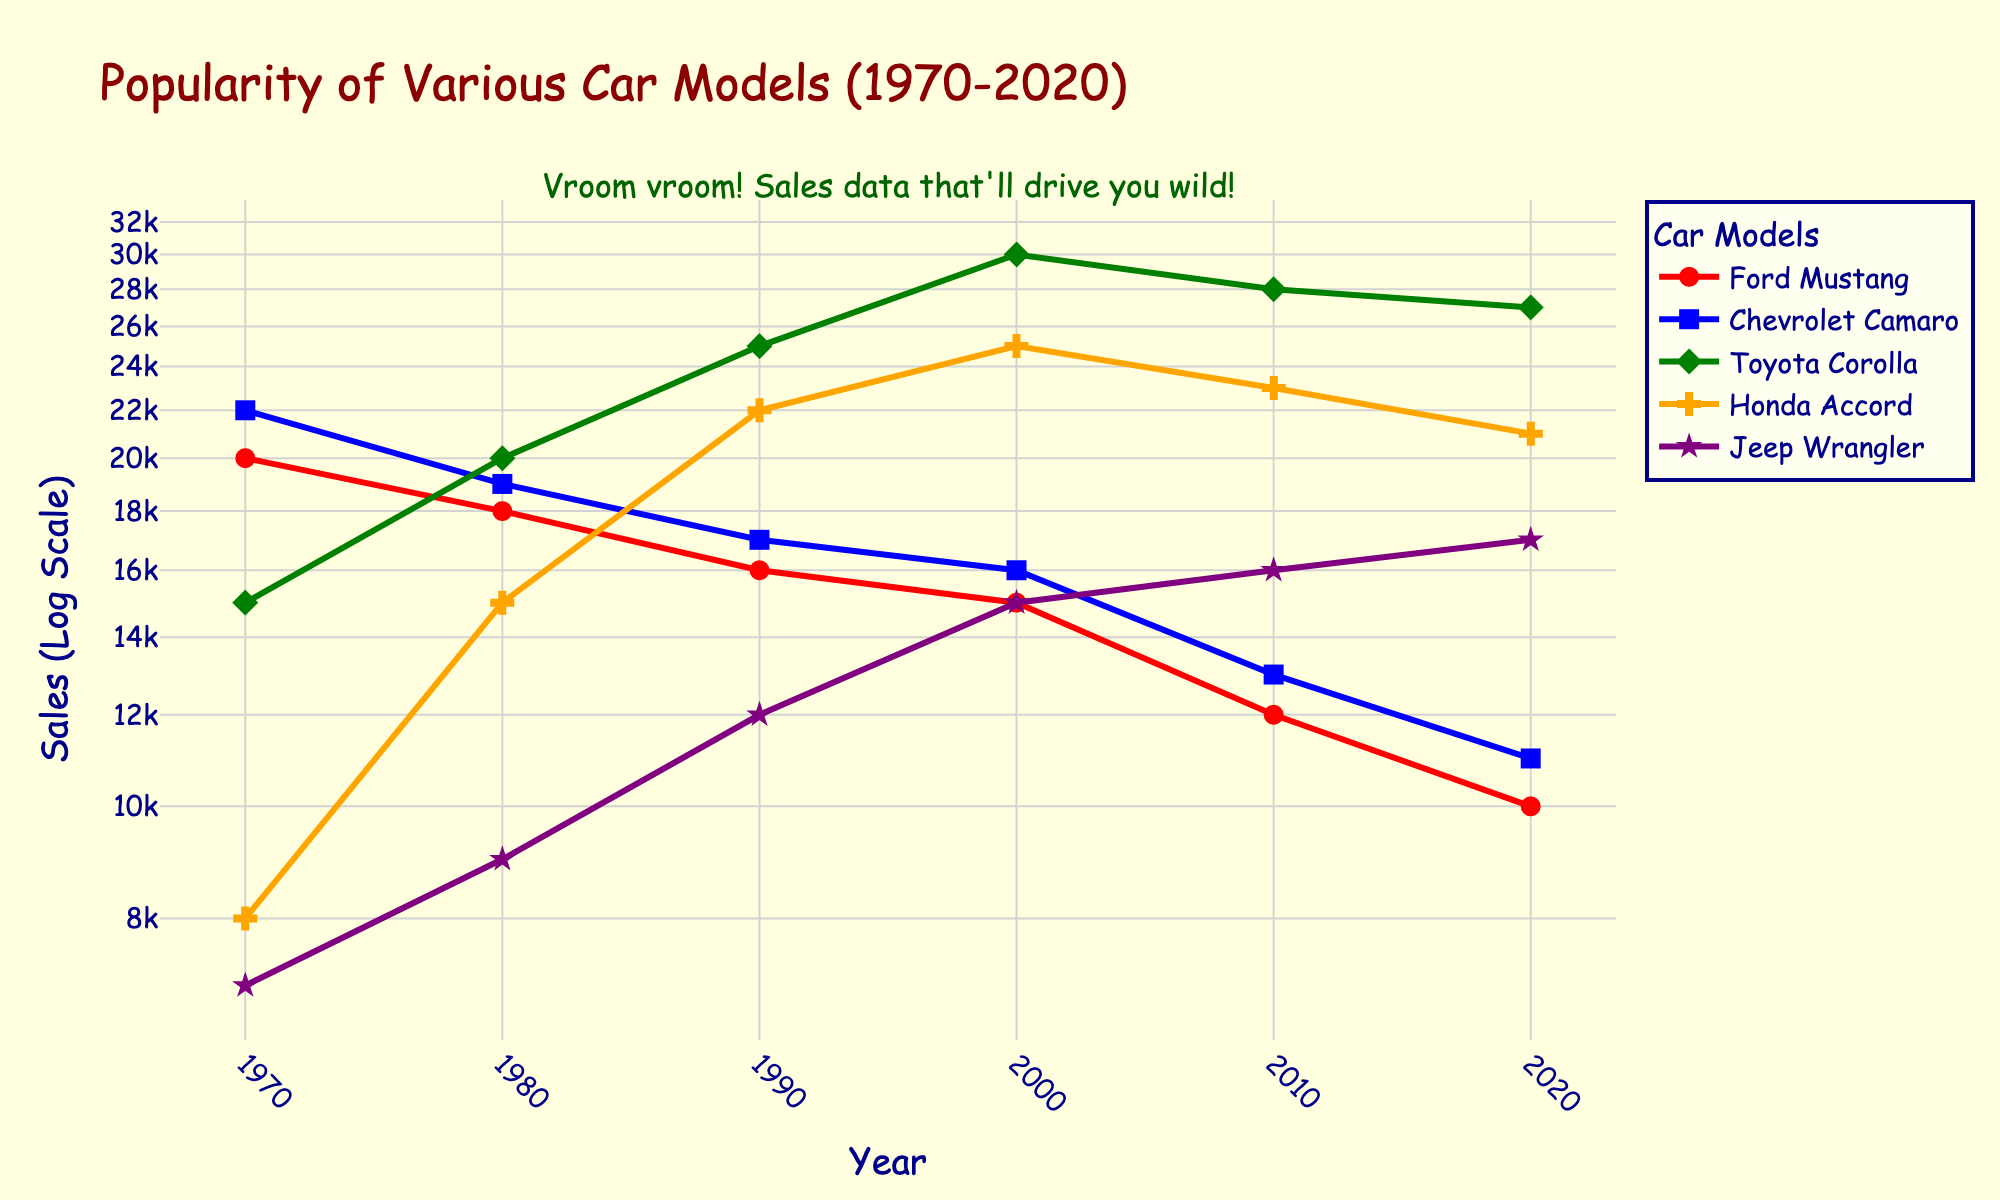What is the title of the figure? The title of the figure is displayed prominently at the top and reads "Popularity of Various Car Models (1970-2020)."
Answer: Popularity of Various Car Models (1970-2020) What does the y-axis represent in the plot? The label on the y-axis indicates it represents the "Sales (Log Scale)," meaning the sales numbers are shown on a logarithmic scale for better visualization of differences.
Answer: Sales (Log Scale) How many car models are compared in the plot? Analyzing the legend on the right, there are five different car models shown in the plot.
Answer: Five Which car model had the highest sales in 1990? By observing the sales data points for 1990 on the plot, the highest point corresponds to Toyota Corolla.
Answer: Toyota Corolla Which car model shows a general increase in sales over the years? Examining the trend lines for all models from 1970 to 2020, only the Toyota Corolla shows an overall increasing trend in sales.
Answer: Toyota Corolla Which car model had the lowest sales in 1970? Looking at the sales data points for 1970, the lowest point corresponds to the Jeep Wrangler.
Answer: Jeep Wrangler Compare the sales of the Ford Mustang and Honda Accord in 2020. Which one sold more? Checking the sales points for both Ford Mustang and Honda Accord in 2020, the Honda Accord sold more units than the Ford Mustang.
Answer: Honda Accord What is the rate of sales decrease for the Ford Mustang from 1970 to 2020? The Ford Mustang sales drop from 20,000 in 1970 to 10,000 in 2020. This can be calculated as a percentage decrease: ((20,000 - 10,000) / 20,000) * 100 = 50%.
Answer: 50% What is the difference in sales between the Chevrolet Camaro and Toyota Corolla in 1980? First, find the sales for Chevrolet Camaro in 1980 (19,000) and Toyota Corolla in 1980 (20,000). The difference is 20,000 - 19,000 = 1,000 units.
Answer: 1,000 units Which car model sales in 2020 are closest to the sales of Toyota Corolla in 2000? The Toyota Corolla had 30,000 sales in 2000. The car model with the closest 2020 sales is the Honda Accord with 21,000, compared to the next highest, Toyota Corolla's 27,000 in 2020.
Answer: Honda Accord 